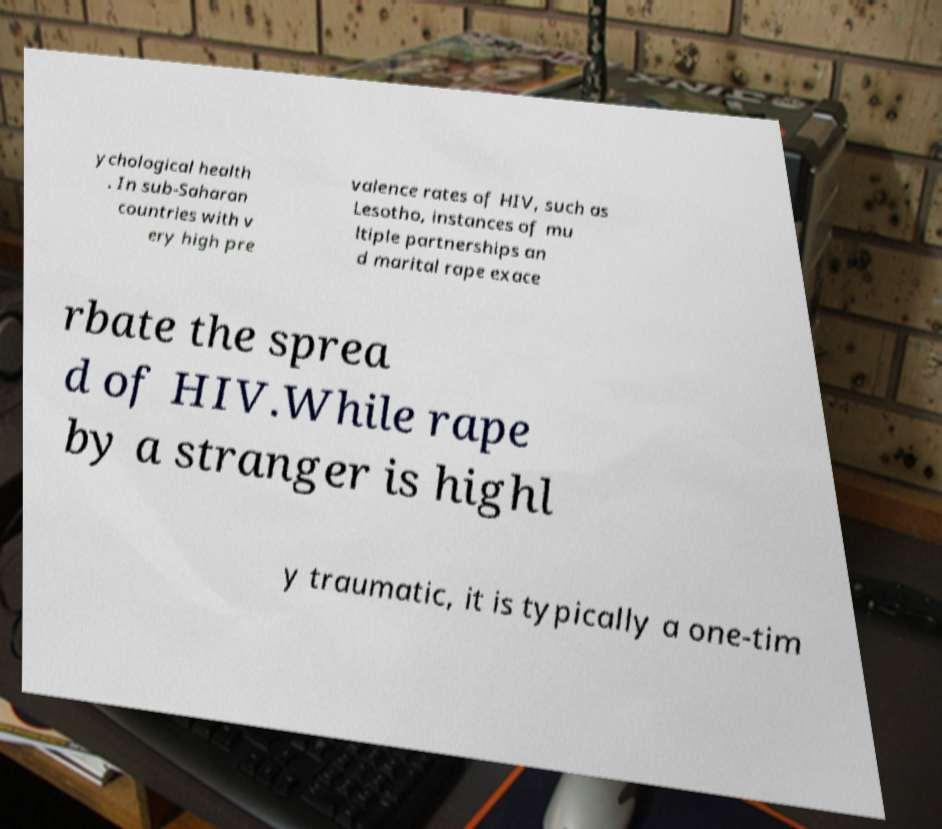Can you accurately transcribe the text from the provided image for me? ychological health . In sub-Saharan countries with v ery high pre valence rates of HIV, such as Lesotho, instances of mu ltiple partnerships an d marital rape exace rbate the sprea d of HIV.While rape by a stranger is highl y traumatic, it is typically a one-tim 